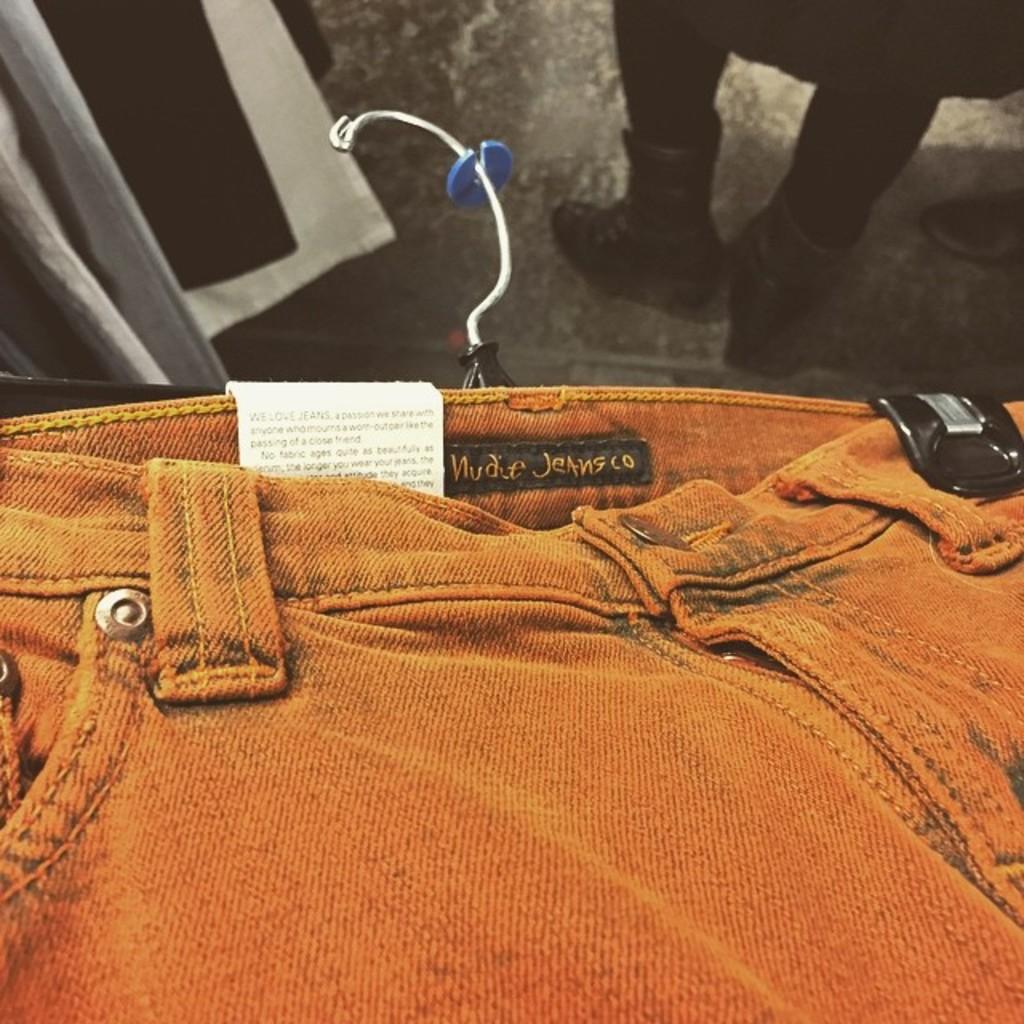Please provide a concise description of this image. It is a jeans trouser. 